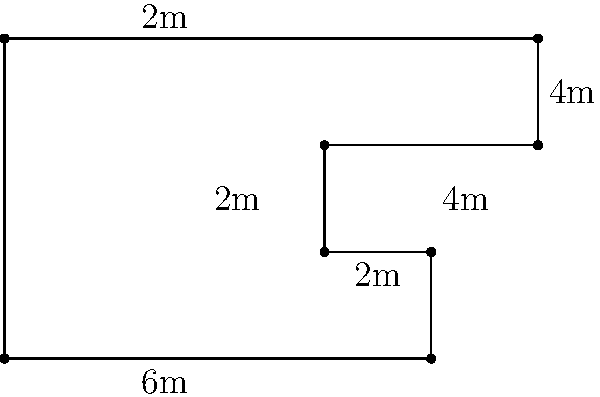As a literary editor with a keen eye for detail, you're designing a custom bookshelf for your home office. The shelf has an irregular shape to accommodate various book sizes and create an artistic display. Given the dimensions shown in the diagram (in meters), calculate the perimeter of this unique bookshelf. How might this unconventional design reflect your belief in authors taking control of their work, similar to negotiating their own contracts? To calculate the perimeter of the bookshelf, we need to sum up all the outer edges:

1. Bottom edge: $6$ m
2. Right side (bottom to first shelf): $2$ m
3. First shelf (right to left): $2$ m
4. Left side (first shelf to second shelf): $2$ m
5. Second shelf (left to right): $4$ m
6. Right side (second shelf to top): $2$ m
7. Top edge: $10$ m
8. Left side (top to bottom): $6$ m

Adding all these lengths:
$$6 + 2 + 2 + 2 + 4 + 2 + 10 + 6 = 34$$

The perimeter of the bookshelf is 34 meters.

This unconventional design reflects the belief in authors taking control of their work by:
1. Breaking away from traditional, uniform shelving units, symbolizing a departure from standard publishing practices.
2. Accommodating various book sizes, representing the diverse needs of different authors and projects.
3. Creating a unique, eye-catching display that stands out, much like how direct author negotiations can lead to more personalized, advantageous contracts.
Answer: 34 meters 